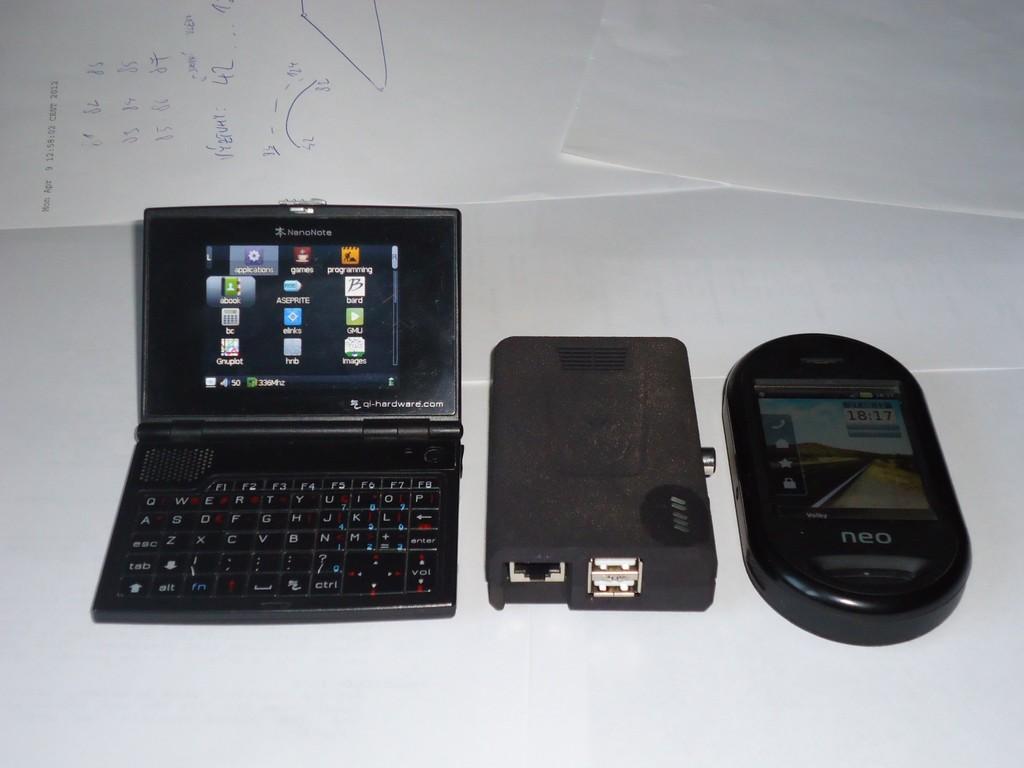What is the time displayed on the device to the right?
Provide a short and direct response. 18:17. 